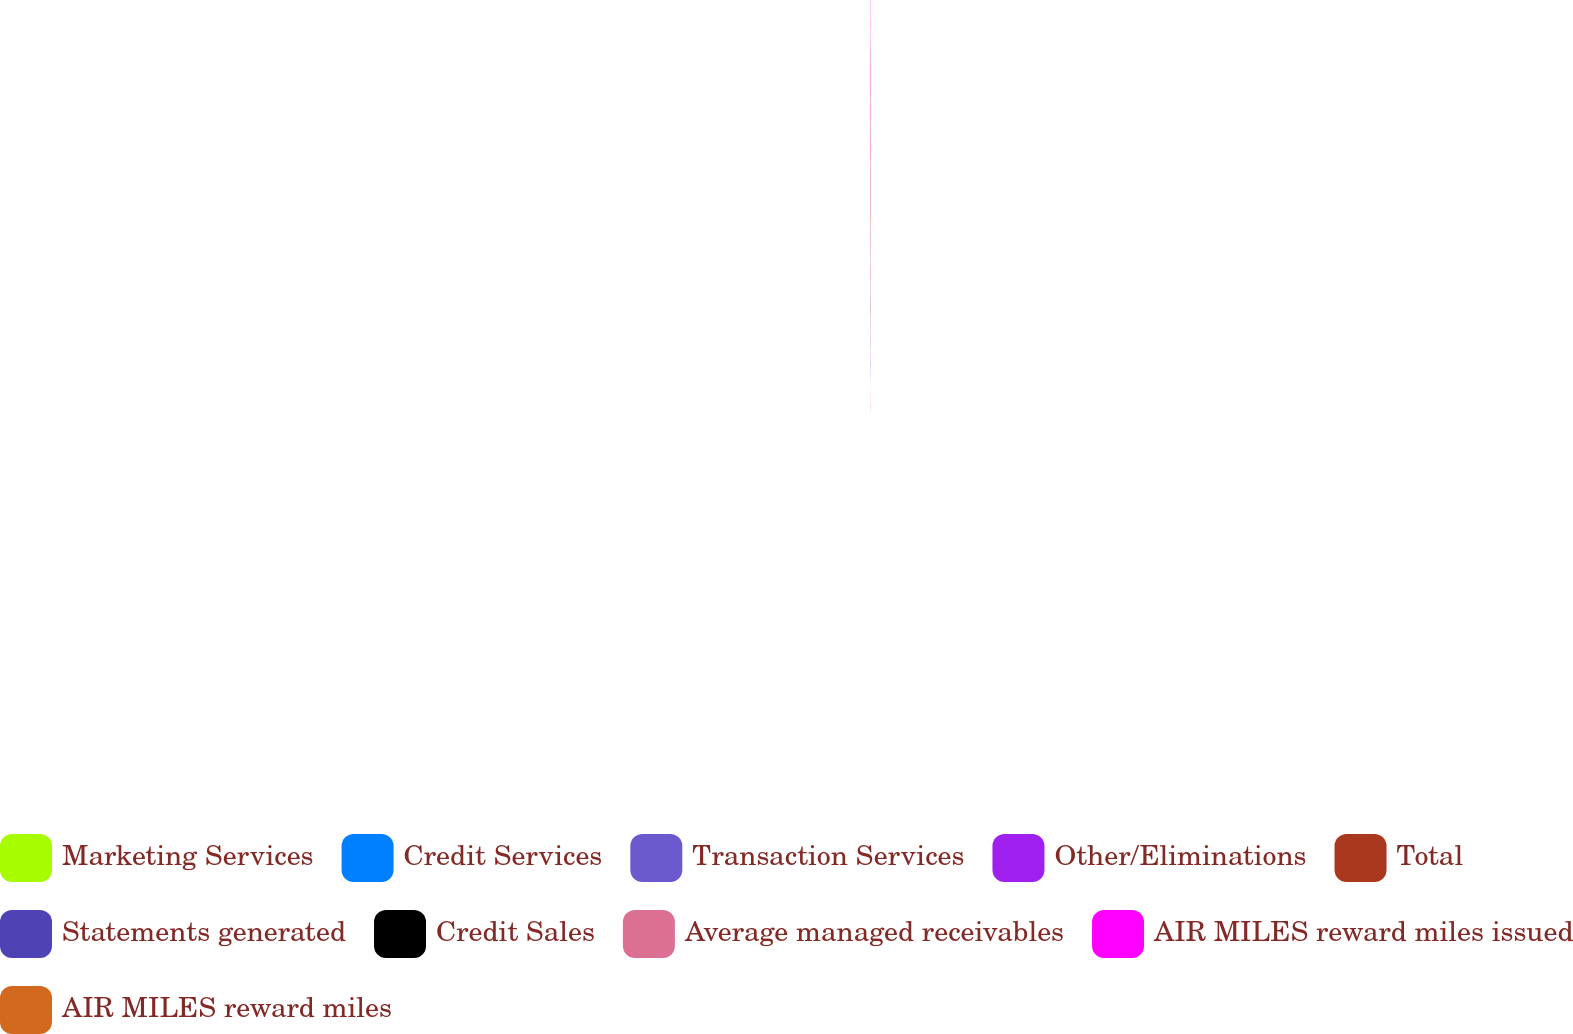<chart> <loc_0><loc_0><loc_500><loc_500><pie_chart><fcel>Marketing Services<fcel>Credit Services<fcel>Transaction Services<fcel>Other/Eliminations<fcel>Total<fcel>Statements generated<fcel>Credit Sales<fcel>Average managed receivables<fcel>AIR MILES reward miles issued<fcel>AIR MILES reward miles<nl><fcel>11.92%<fcel>8.05%<fcel>4.04%<fcel>0.02%<fcel>17.94%<fcel>2.03%<fcel>6.05%<fcel>15.93%<fcel>20.1%<fcel>13.92%<nl></chart> 